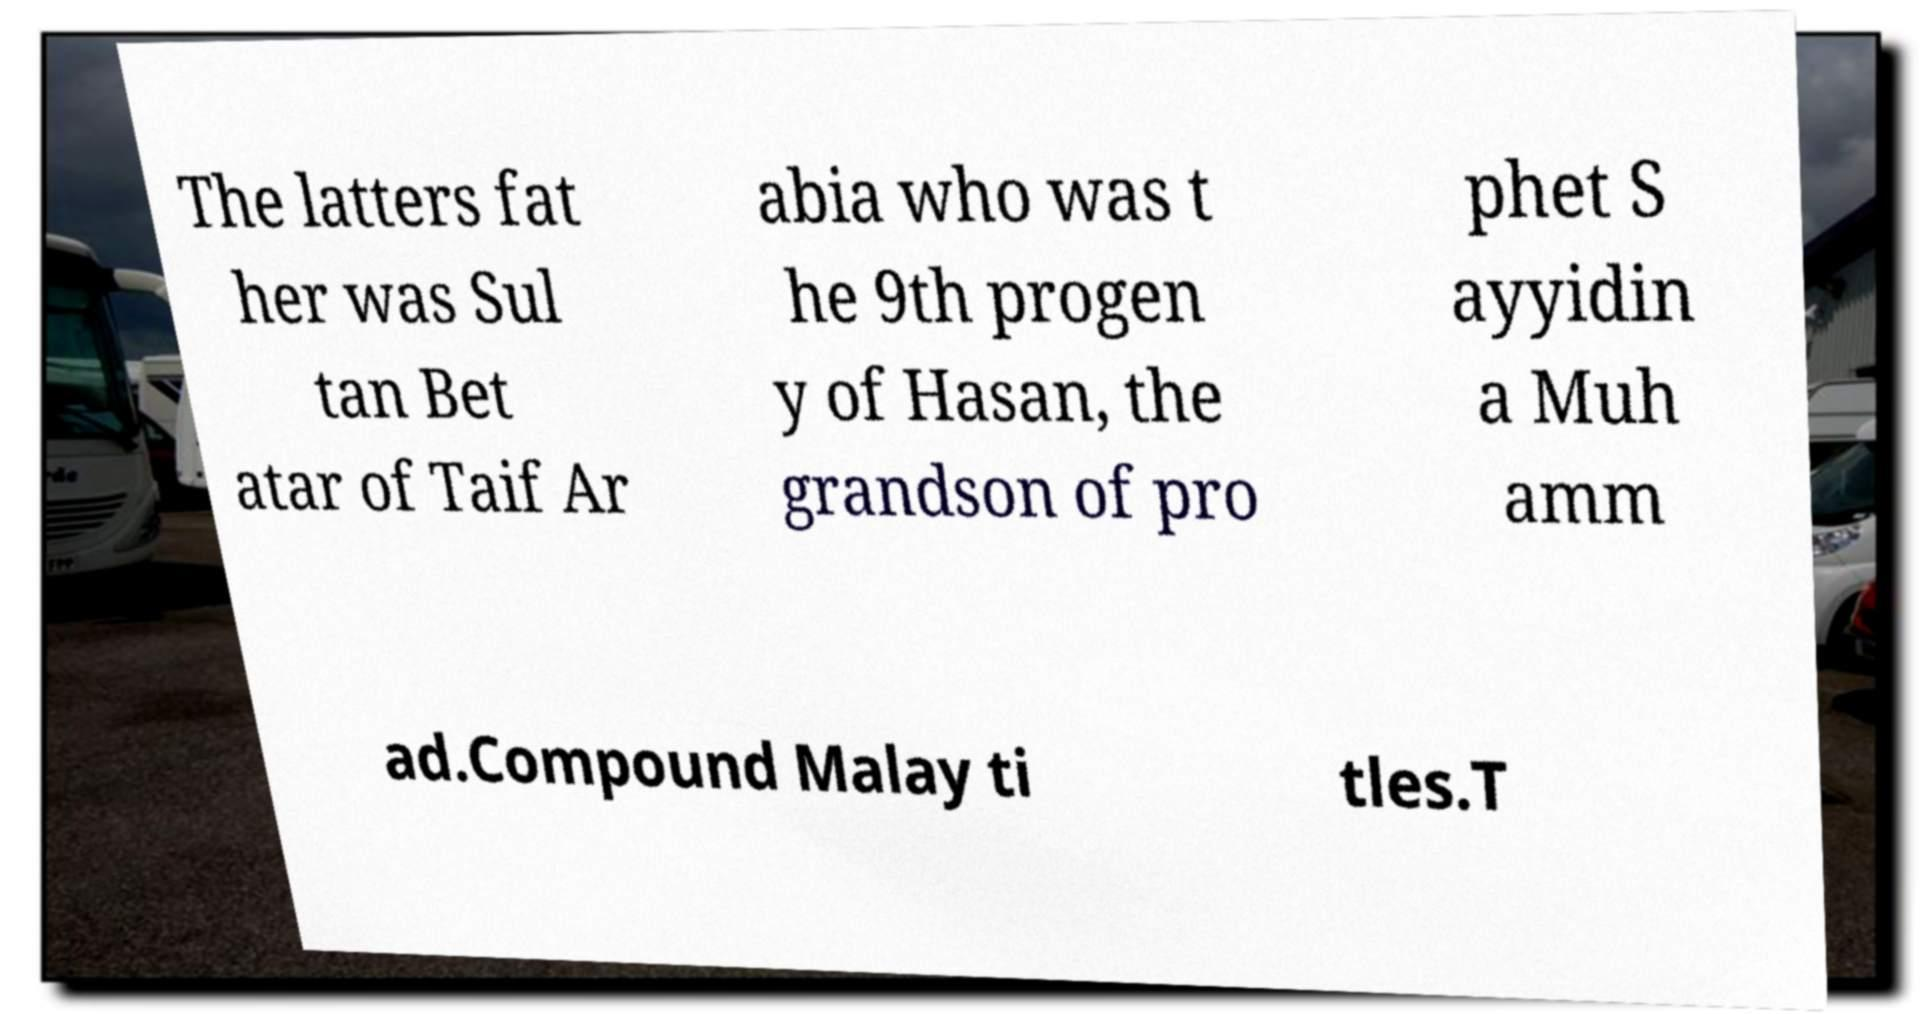There's text embedded in this image that I need extracted. Can you transcribe it verbatim? The latters fat her was Sul tan Bet atar of Taif Ar abia who was t he 9th progen y of Hasan, the grandson of pro phet S ayyidin a Muh amm ad.Compound Malay ti tles.T 